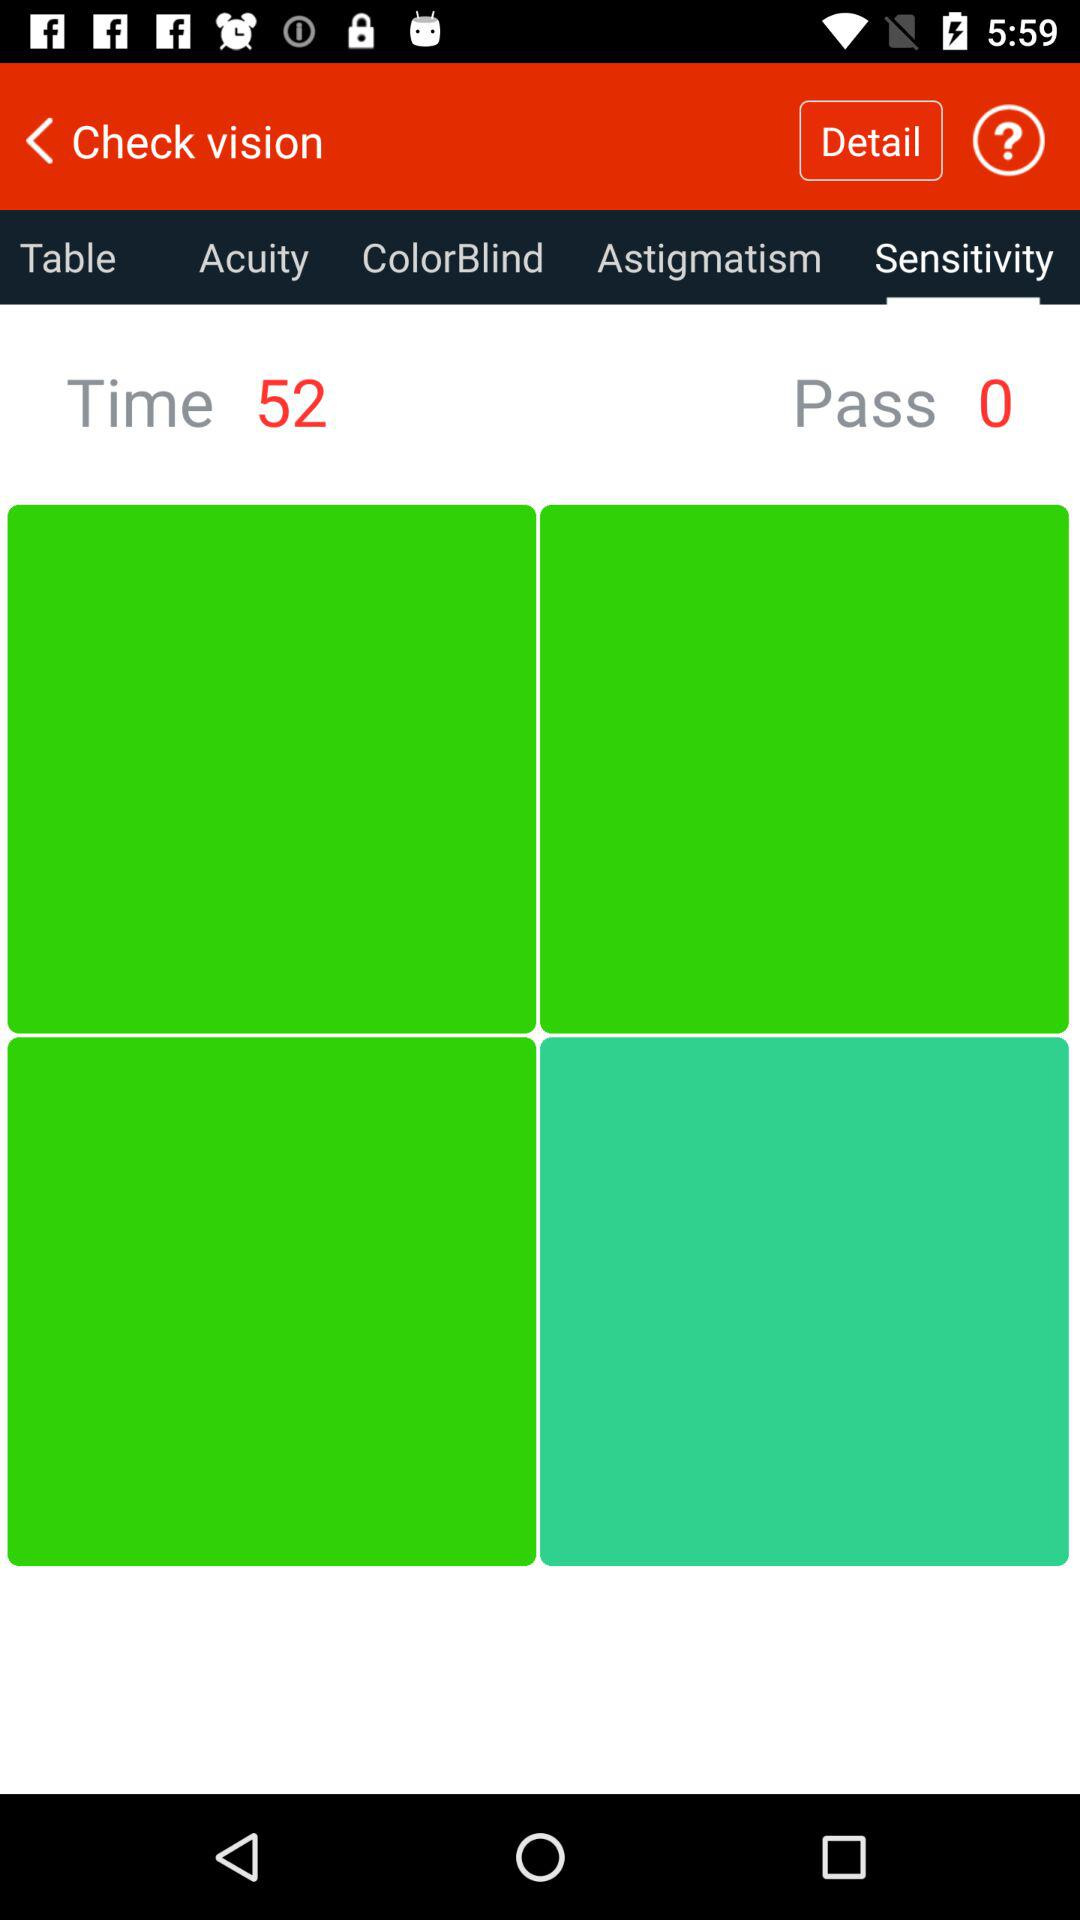What is the time? The time is 52. 